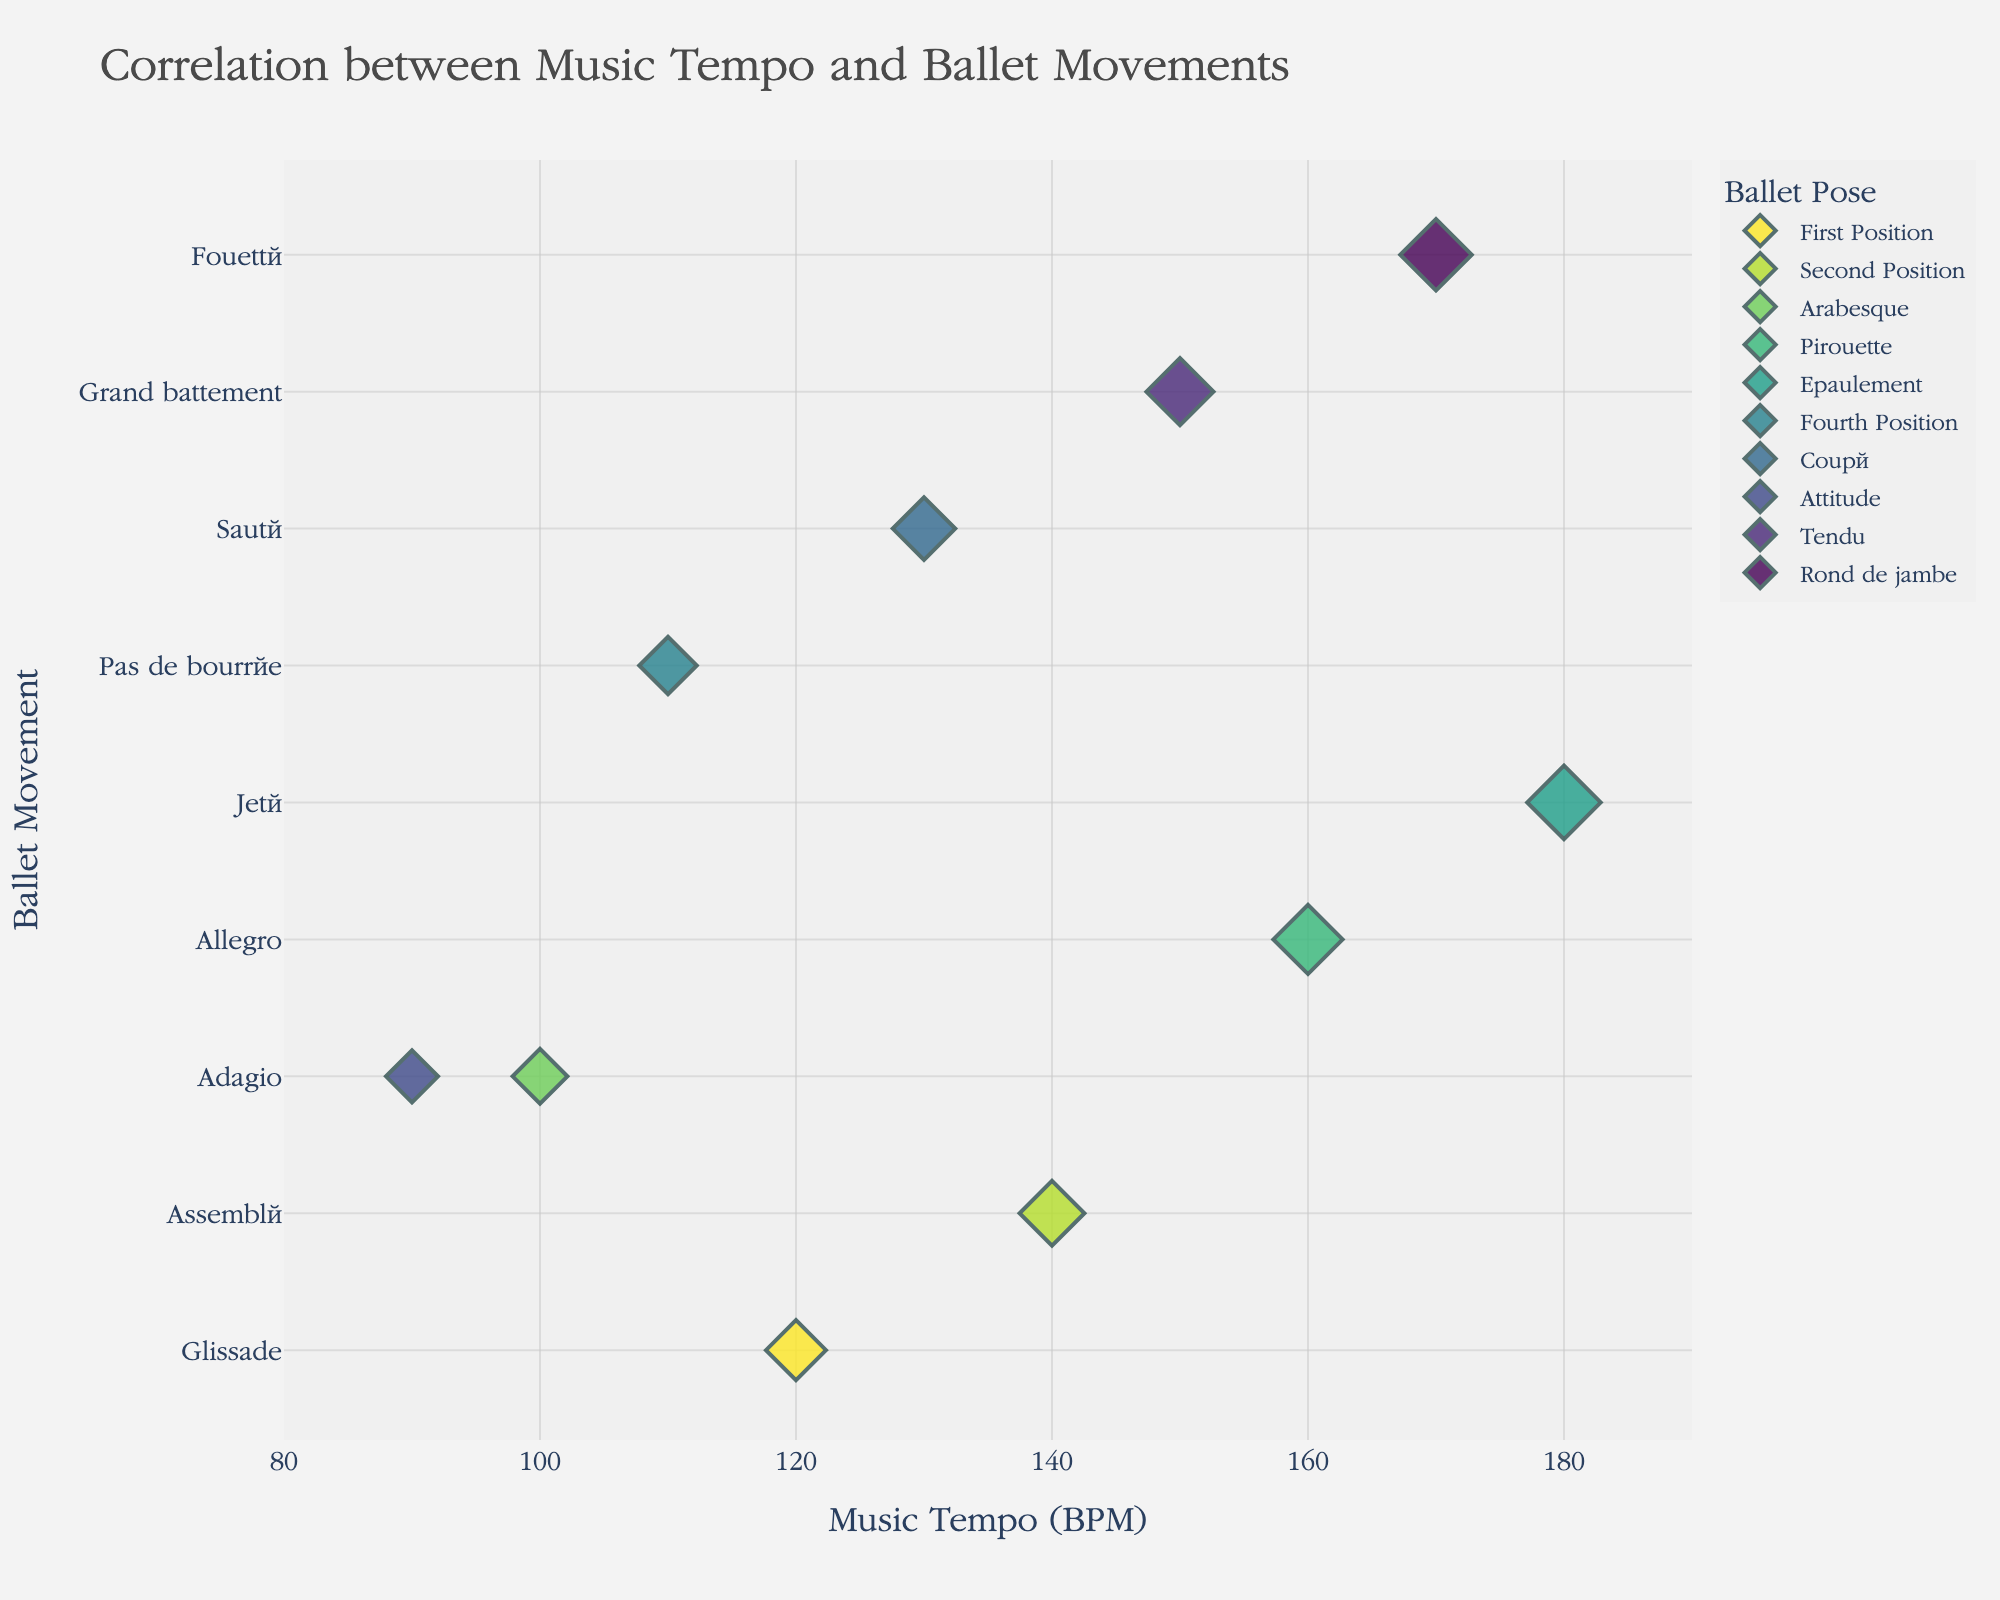what is the title of the plot? The title of the plot is displayed at the top of the figure and usually summarizes the main goal or objective of the plot. In this case, look closely at the text at the top.
Answer: Correlation between Music Tempo and Ballet Movements How many different ballet poses are shown in the figure? Identify the legend or look at the unique values in the data points marked by different colors. Count each distinct ballet pose.
Answer: 10 Which ballet movement corresponds to the lowest tempo? Locate the data point with the lowest x-axis value (Tempo) and note the ballet movement associated with it.
Answer: Adagio What is the music tempo for the Jeté movement? Find the data point labeled "Jeté" on the y-axis and look at its corresponding x-axis value to determine the music tempo.
Answer: 180 BPM How many ballet movements have a tempo greater than 150 BPM? Identify data points with x-axis values (Tempo) greater than 150 and count them.
Answer: 3 Compare the tempo of Allegro and Adagio. Which has a higher tempo? Locate the data points for Allegro and Adagio and compare their x-axis values. The one with a higher value has a higher tempo.
Answer: Allegro What ballet movement corresponds to the Fourth Position pose? Identify the data point with the hover data or annotation for "Fourth Position" and trace it to the ballet movement on the y-axis.
Answer: Pas de bourrée What is the average tempo of all ballet movements? Add together all the x-axis values (Tempos) and divide by the number of data points to get the average tempo. (120 + 140 + 100 + 160 + 180 + 110 + 130 + 90 + 150 + 170) / 10 = 135
Answer: 135 BPM Which ballet pose is associated with the highest tempo? Find the data point with the highest x-axis value (Tempo) and note the ballet pose associated with it.
Answer: Epaulement 